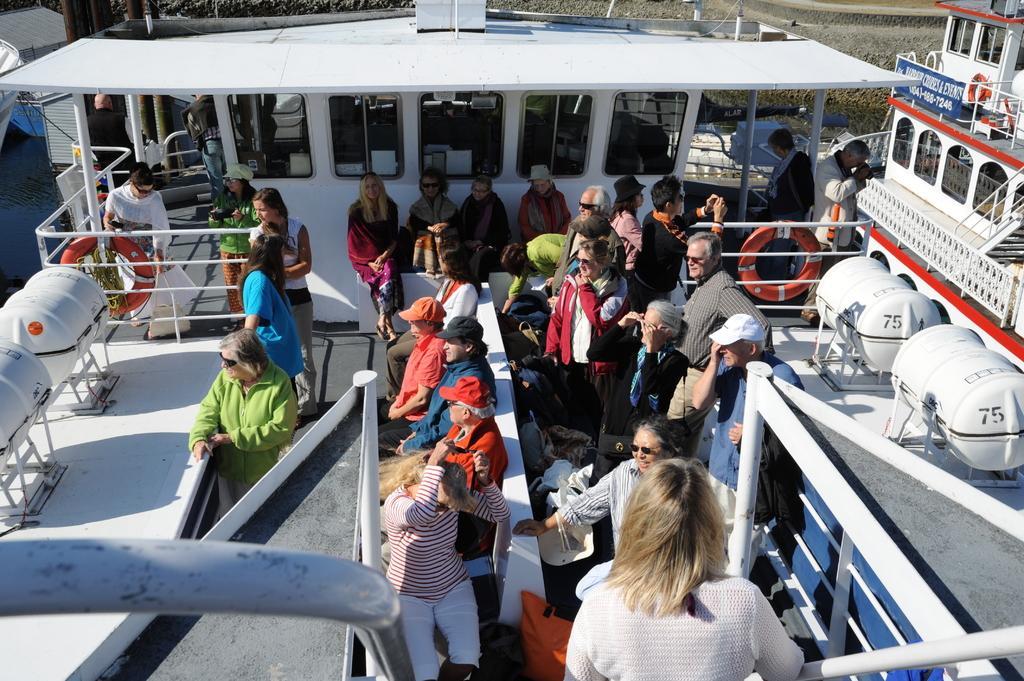In one or two sentences, can you explain what this image depicts? In this picture we can see a ship, in which we can see some people among them few people are sitting and few people are standing and watching. 